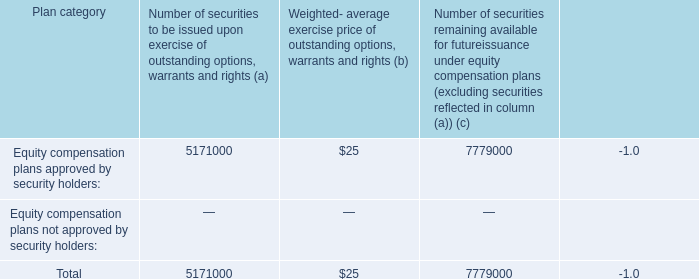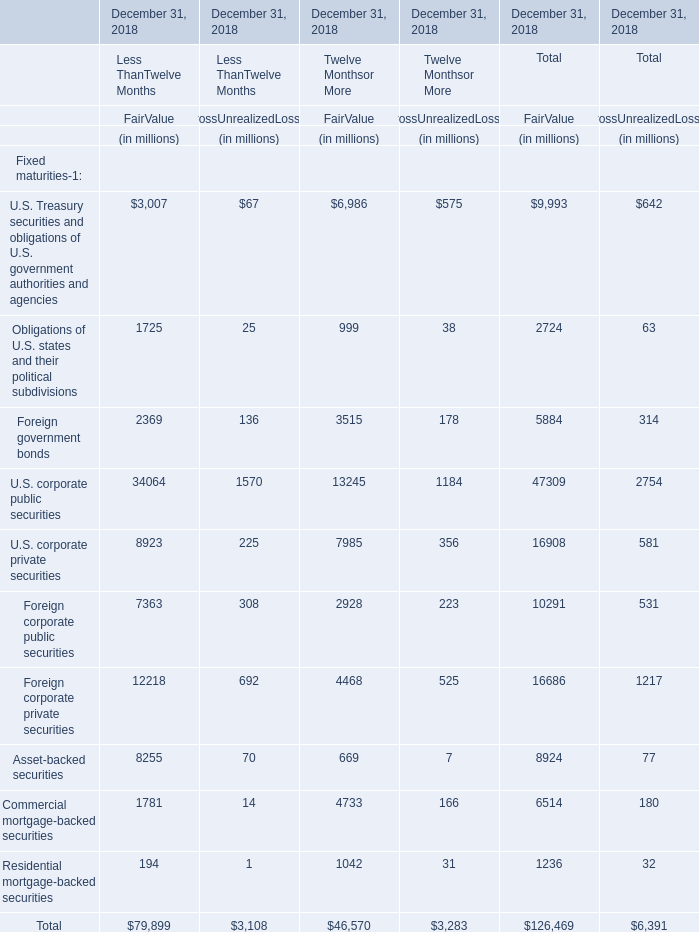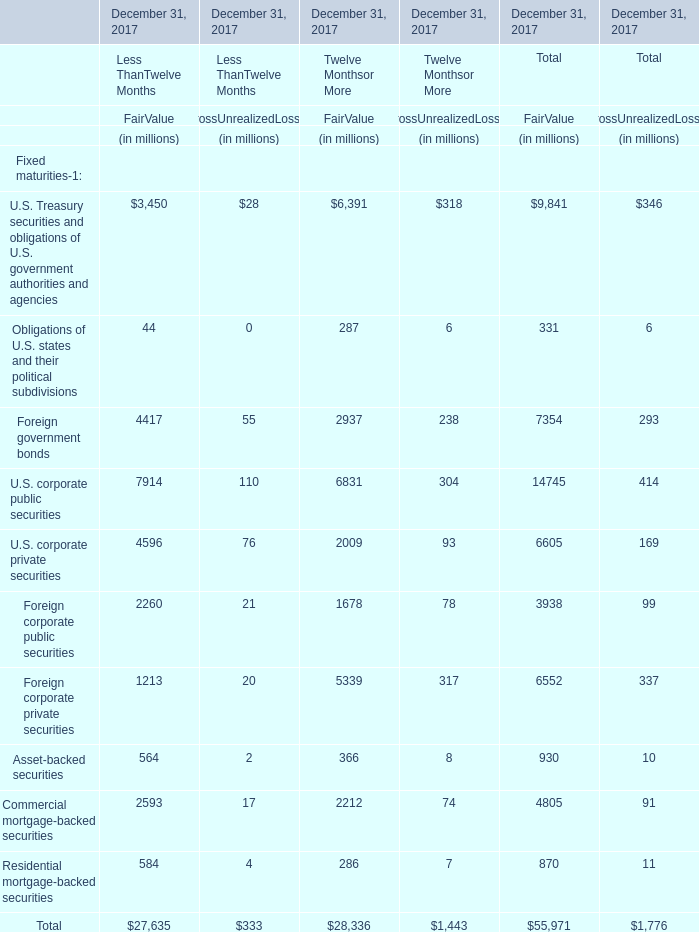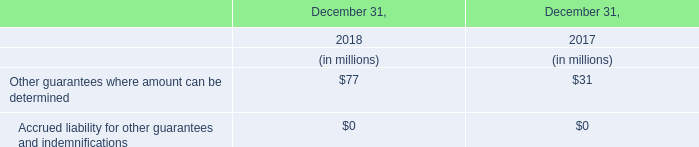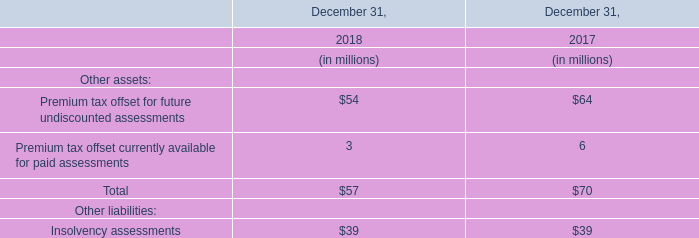What's the 15 % of total elements for FairValue of Total in 2017? (in million) 
Computations: (55971 * 0.15)
Answer: 8395.65. 